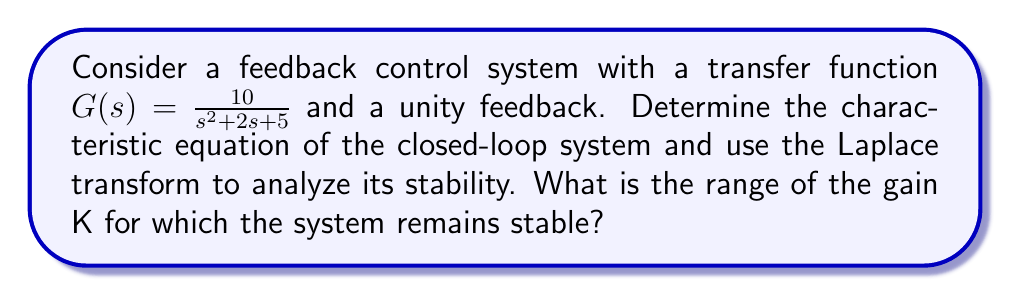Give your solution to this math problem. To analyze the stability of the feedback control system, we'll follow these steps:

1) First, let's recall that for a unity feedback system, the closed-loop transfer function is given by:

   $$T(s) = \frac{KG(s)}{1 + KG(s)}$$

   where K is the forward path gain.

2) The characteristic equation is the denominator of T(s) set to zero:

   $$1 + KG(s) = 0$$

3) Substituting the given transfer function:

   $$1 + K(\frac{10}{s^2 + 2s + 5}) = 0$$

4) Multiplying both sides by $(s^2 + 2s + 5)$:

   $$s^2 + 2s + 5 + 10K = 0$$

5) This is our characteristic equation. For the system to be stable, all roots of this equation must have negative real parts.

6) We can use the Routh-Hurwitz stability criterion to determine the range of K for stability. The Routh array for this system is:

   $$\begin{array}{c|cc}
   s^2 & 1 & 5+10K \\
   s^1 & 2 & 0 \\
   s^0 & 5+10K & 0
   \end{array}$$

7) For stability, all elements in the first column must be positive. We already know that 1 and 2 are positive, so we need:

   $$5 + 10K > 0$$

8) Solving this inequality:

   $$10K > -5$$
   $$K > -0.5$$

Therefore, the system is stable for all K > -0.5.
Answer: The system is stable for all K > -0.5. 